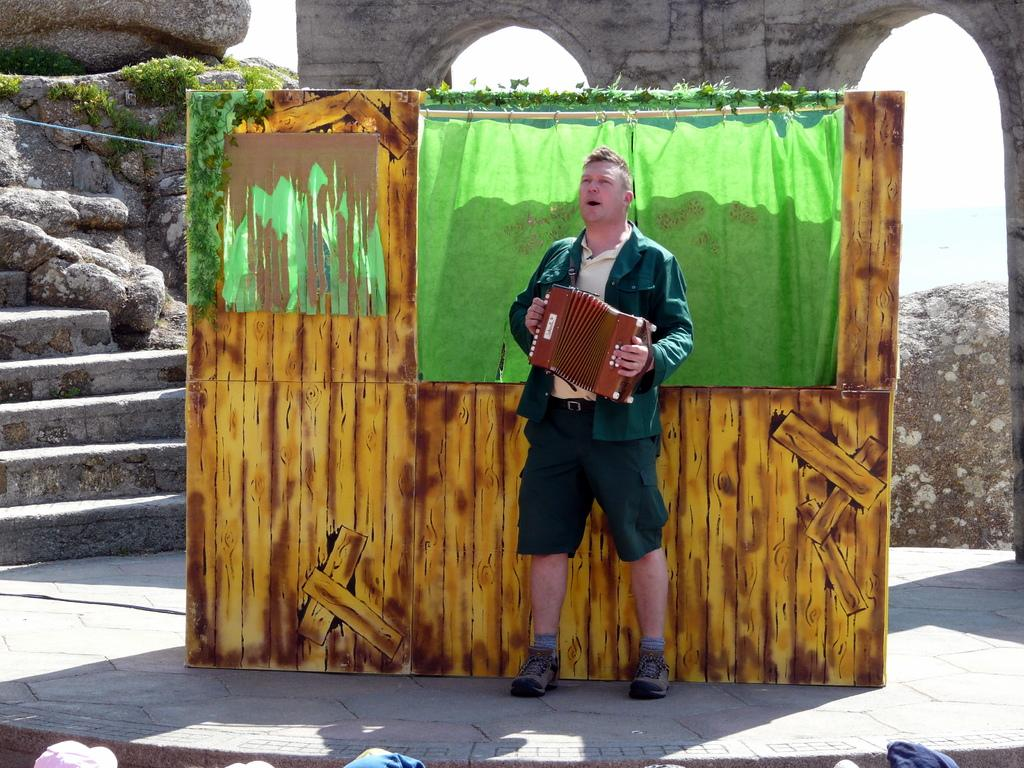What is the person in the image doing? The person is playing musical instruments. What else can be seen in the image besides the person? There is a board, an arch, and stare cases visible in the image. Are there any natural elements present in the image? Yes, there are rocks in the image. What type of crime is being committed in the image? There is no crime being committed in the image; it features a person playing musical instruments and other objects. What color is the shirt worn by the person in the image? The provided facts do not mention the color of the person's shirt, so we cannot determine that information from the image. 